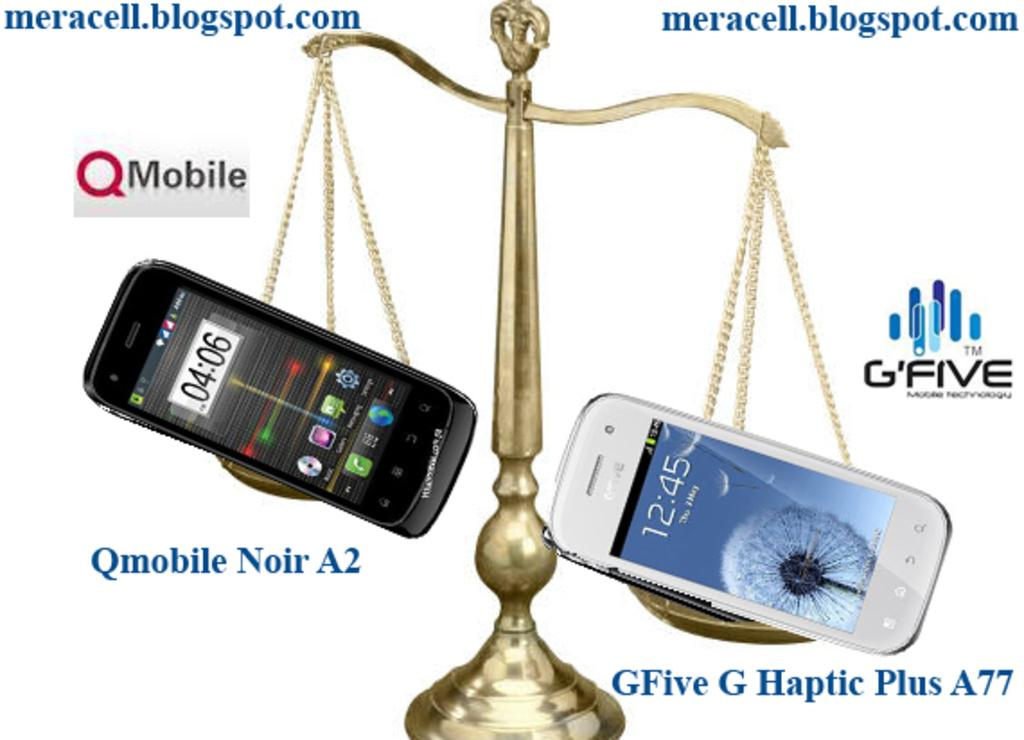Provide a one-sentence caption for the provided image. The GFive G Haptic Plus A77 appears to weight a little more than the Qmobile Noir A2. 